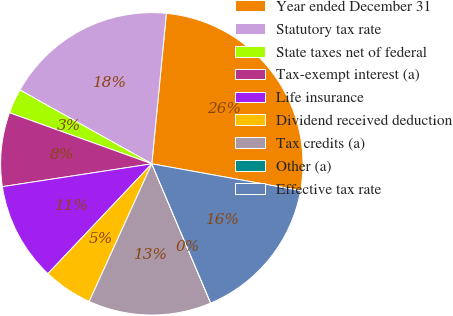Convert chart. <chart><loc_0><loc_0><loc_500><loc_500><pie_chart><fcel>Year ended December 31<fcel>Statutory tax rate<fcel>State taxes net of federal<fcel>Tax-exempt interest (a)<fcel>Life insurance<fcel>Dividend received deduction<fcel>Tax credits (a)<fcel>Other (a)<fcel>Effective tax rate<nl><fcel>26.31%<fcel>18.42%<fcel>2.64%<fcel>7.9%<fcel>10.53%<fcel>5.27%<fcel>13.16%<fcel>0.01%<fcel>15.79%<nl></chart> 